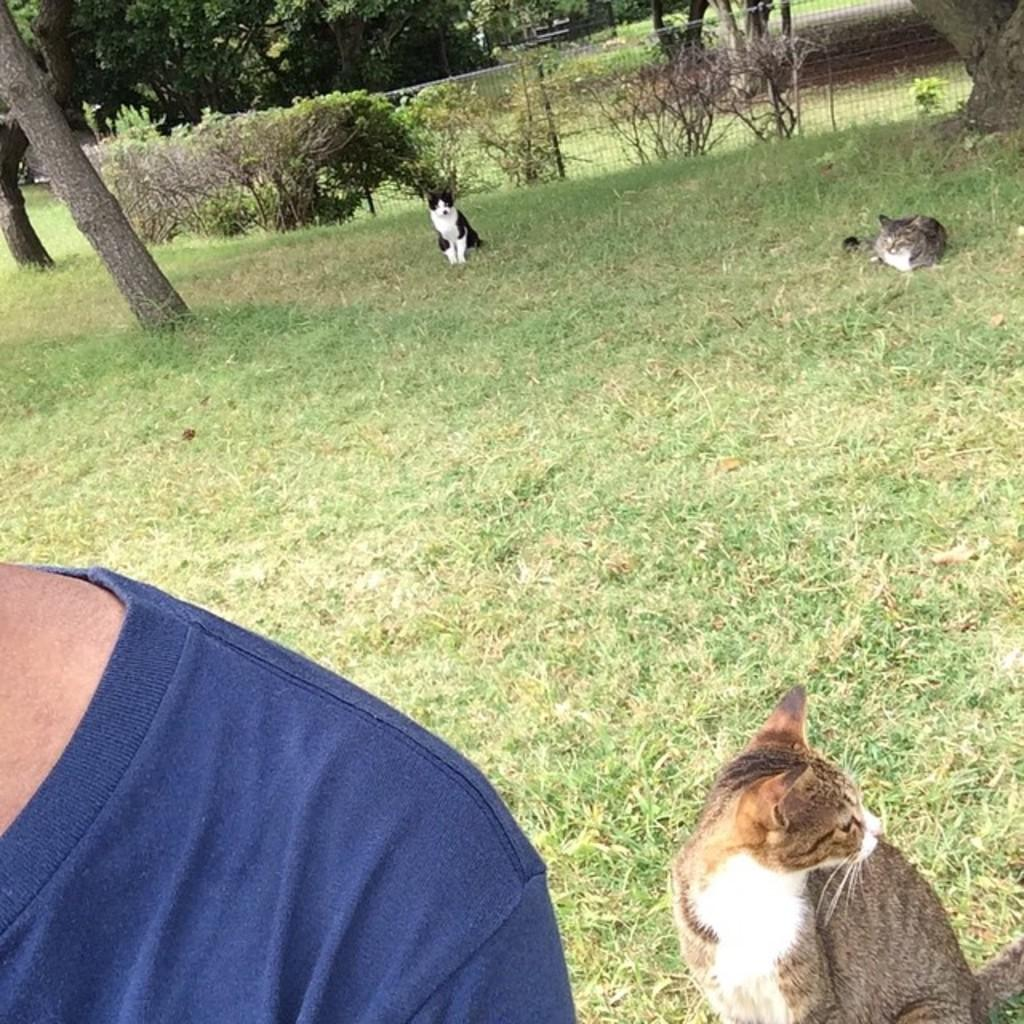Who or what is present in the image? There is a person in the image. What else can be seen on the ground in the image? There are animals on the ground in the image. What can be seen in the distance in the image? There are trees in the background of the image. Are there any structures or features in the background of the image? Yes, there is a fence in the background of the image. Where is the throne located in the image? There is no throne present in the image. Can you describe the fairies flying around the person in the image? There are no fairies present in the image. 